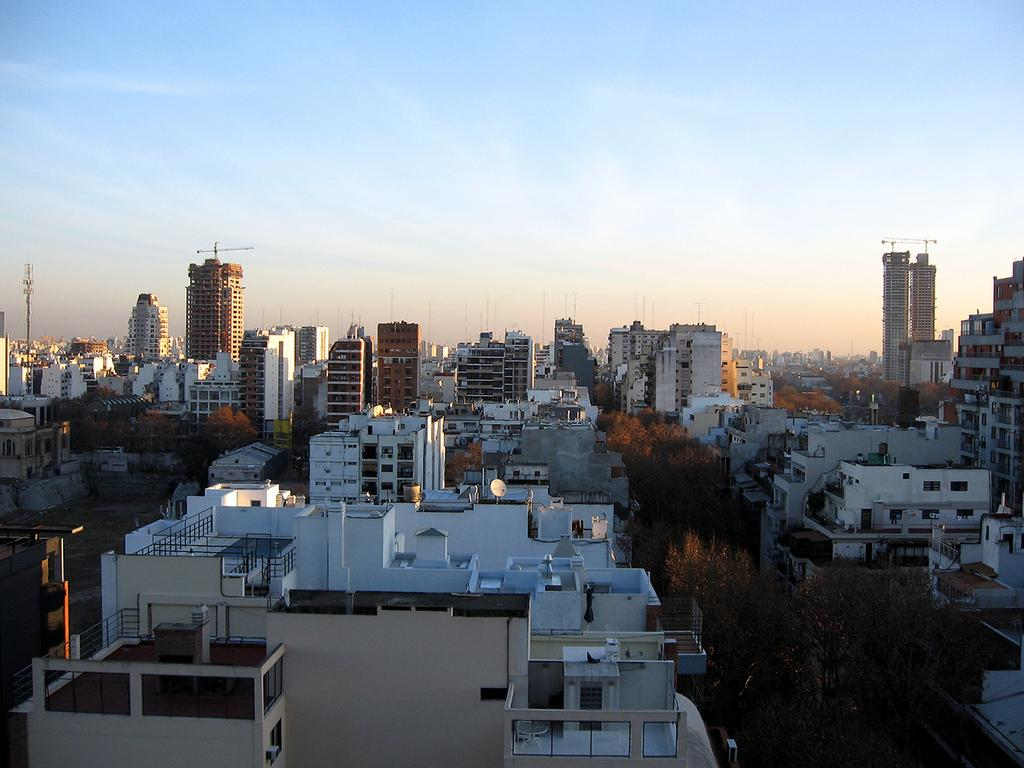What type of natural elements can be seen in the image? There are trees in the image. What type of man-made structures are present in the image? There are buildings in the image. What is visible at the top of the image? The sky is visible at the top of the image. Can you tell me the direction the goldfish is swimming in the image? There is no goldfish present in the image. What type of paper is being used to create the buildings in the image? The buildings in the image are not made of paper; they are actual structures. 